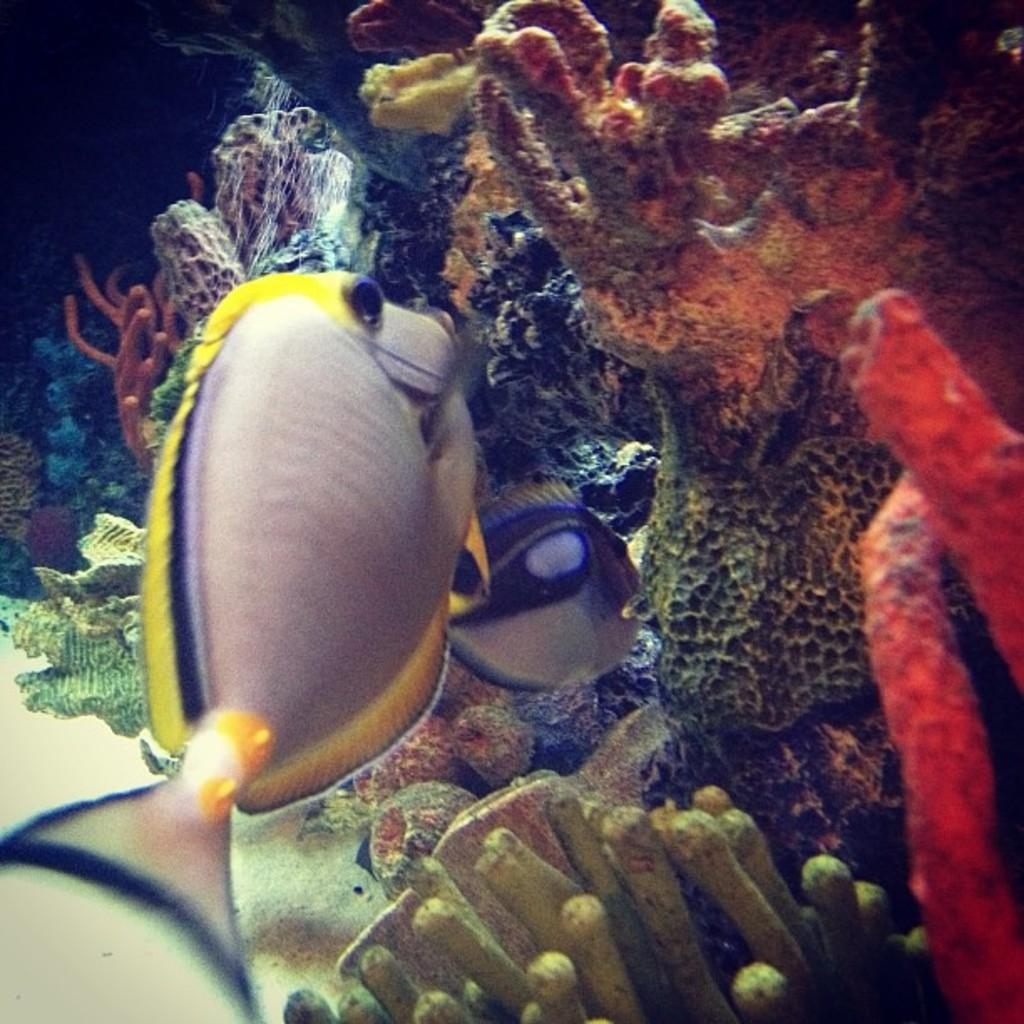What type of animals can be seen in the image? There are fishes in the image. What other living organism is present in the image? There is a plant in the image. What is the primary element visible in the image? There is water visible in the image. What is the name of the daughter of the fishes in the image? There is no daughter mentioned or depicted in the image, as it features fishes and a plant in water. 